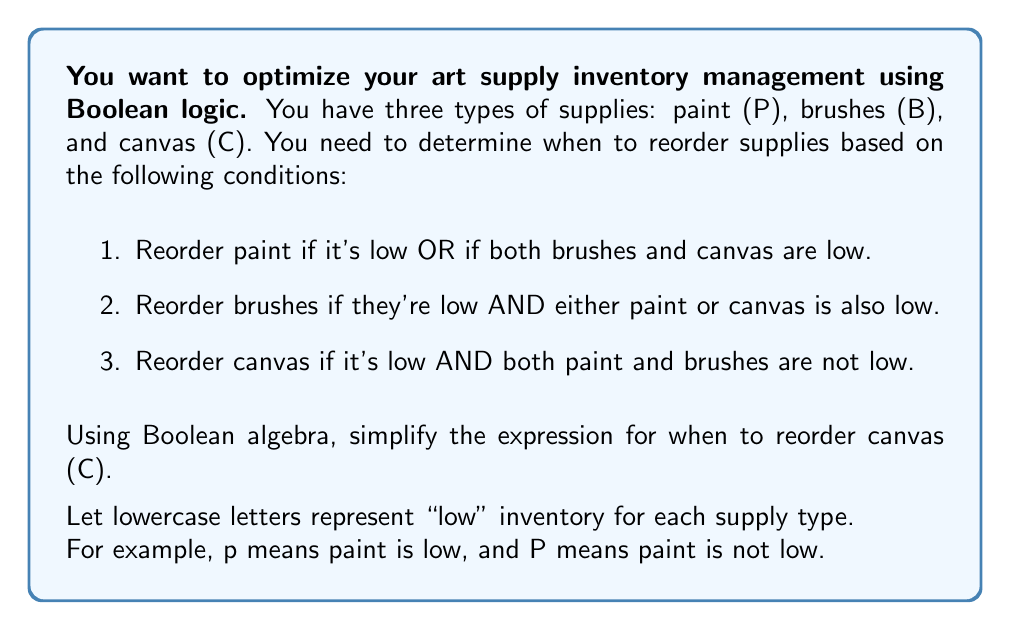Show me your answer to this math problem. Let's approach this step-by-step:

1. First, we need to translate the given condition for reordering canvas into a Boolean expression:

   $C = c \cdot P \cdot B$

2. We can simplify this expression using De Morgan's Law:

   $C = c \cdot \overline{(p + b)}$

3. Expanding the expression:

   $C = c \cdot (\overline{p} \cdot \overline{b})$

4. Using the associative property:

   $C = (c \cdot \overline{p}) \cdot \overline{b}$

5. This is the simplest form of the expression using the given variables.
Answer: $(c \cdot \overline{p}) \cdot \overline{b}$ 